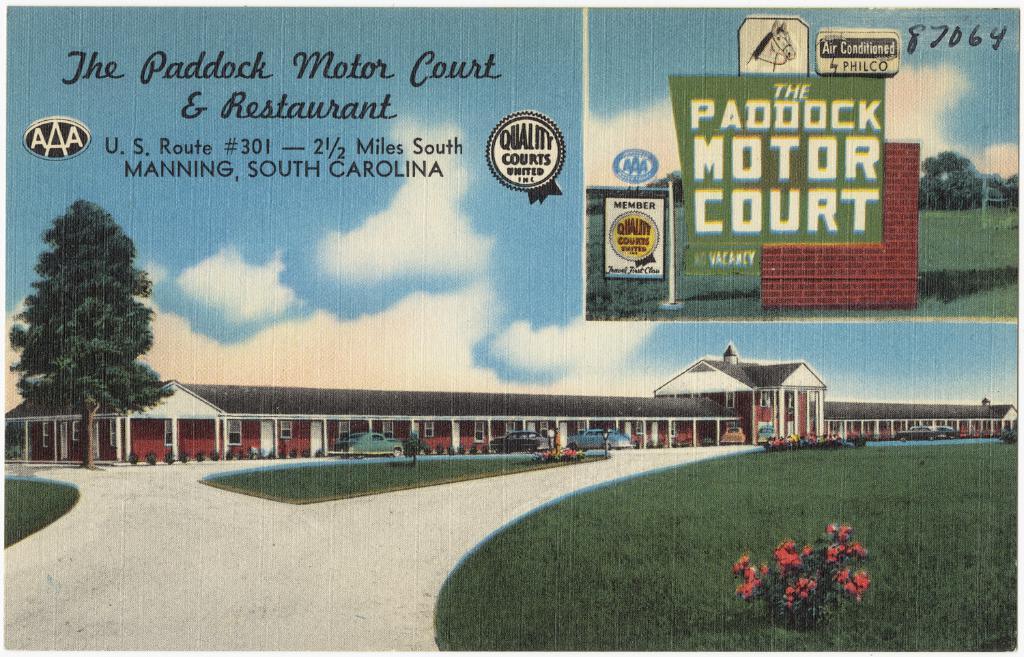What is the address of the paddock motor court & restaurant?
Provide a succinct answer. U.s. route #301. What strett is teh paddock motor court located on?
Keep it short and to the point. U.s. route #301. 